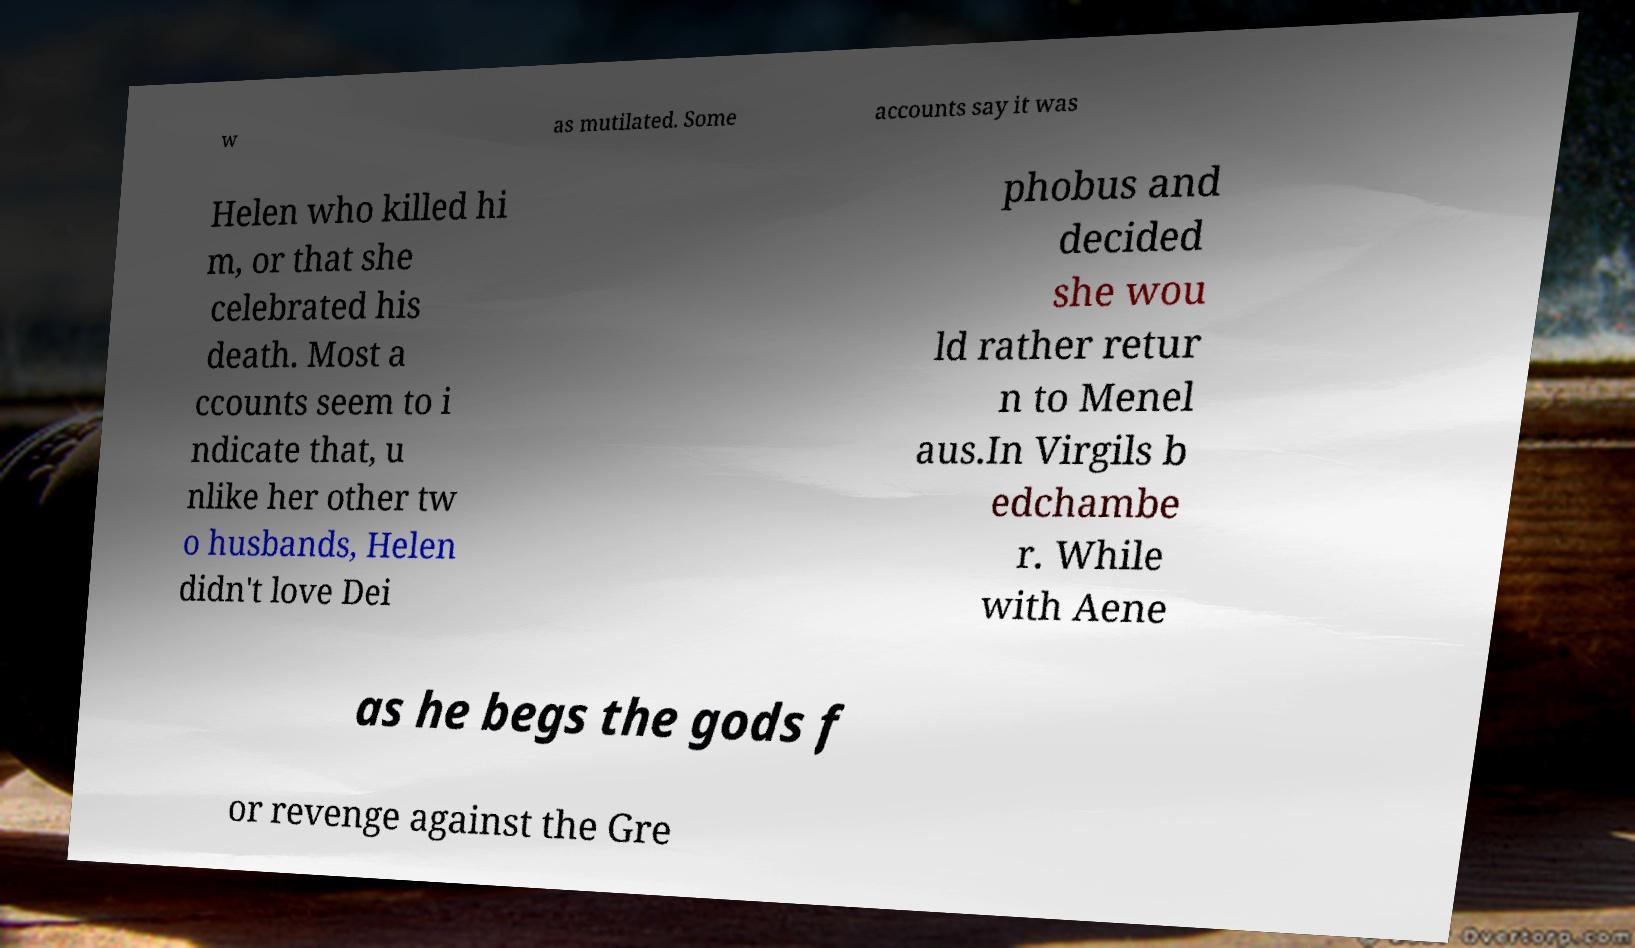Please read and relay the text visible in this image. What does it say? w as mutilated. Some accounts say it was Helen who killed hi m, or that she celebrated his death. Most a ccounts seem to i ndicate that, u nlike her other tw o husbands, Helen didn't love Dei phobus and decided she wou ld rather retur n to Menel aus.In Virgils b edchambe r. While with Aene as he begs the gods f or revenge against the Gre 